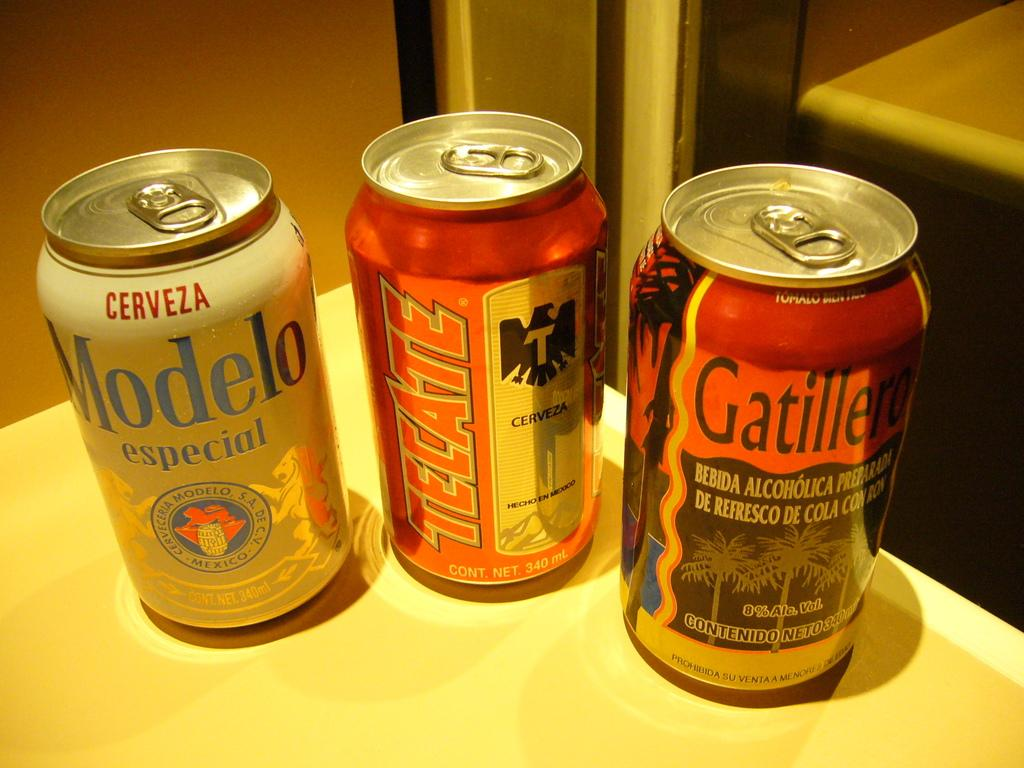<image>
Render a clear and concise summary of the photo. Three cans of beer, including a Modelo and a Tecate. 